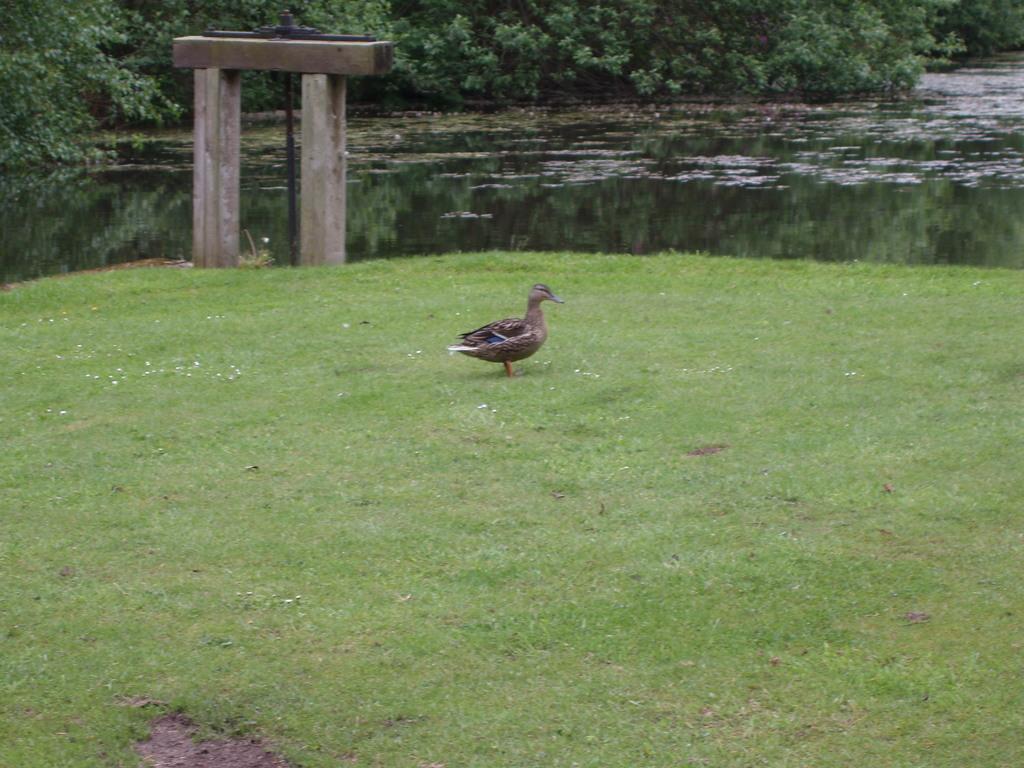Can you describe this image briefly? In the image we can see the bird, grass and cement construction. Here we can see the water and plants. 